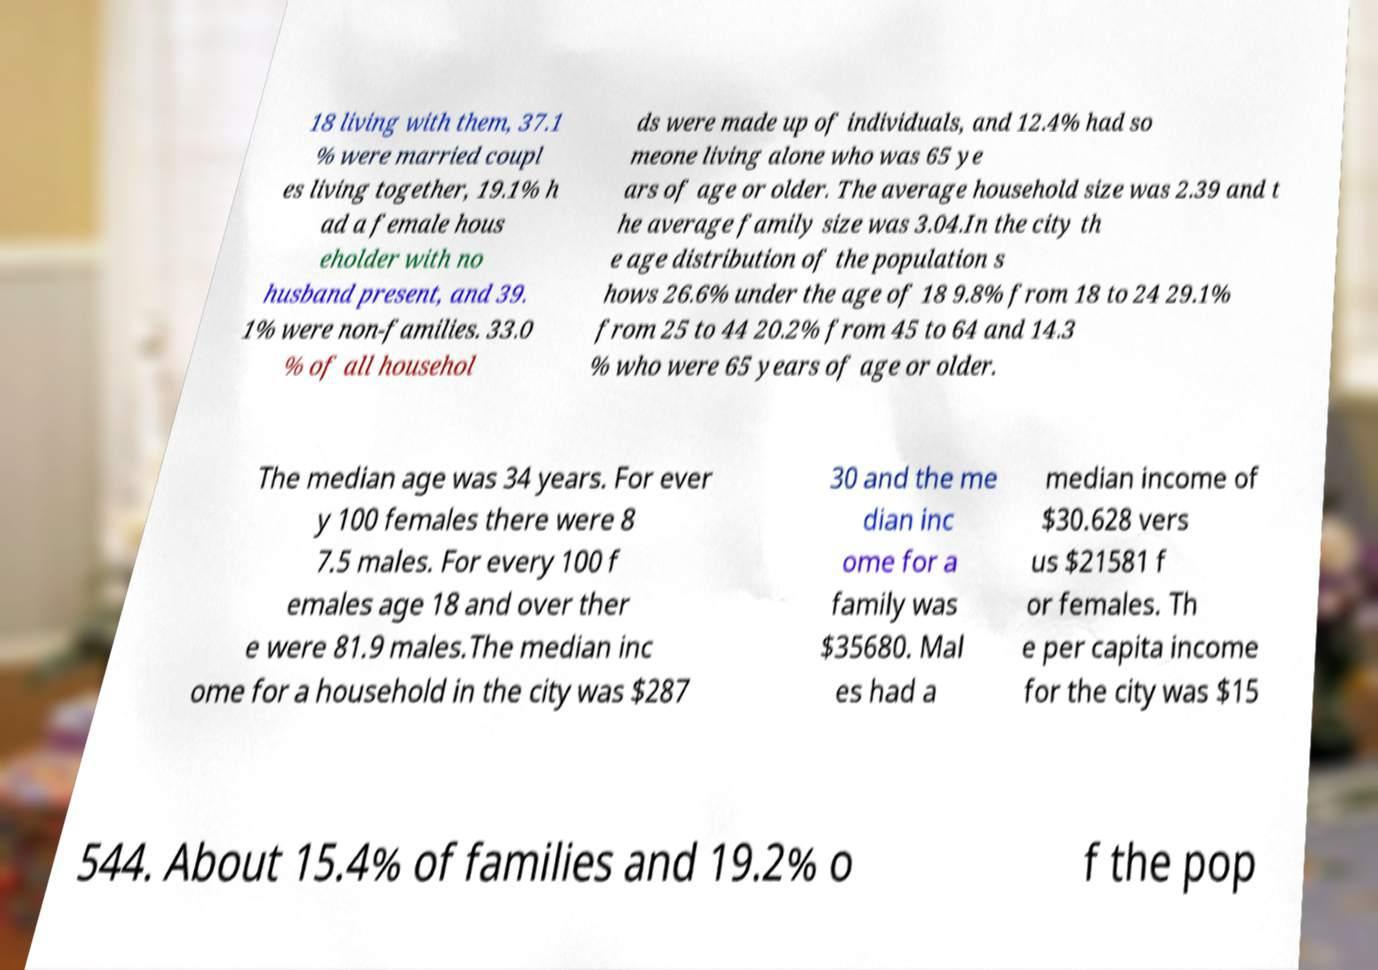Could you assist in decoding the text presented in this image and type it out clearly? 18 living with them, 37.1 % were married coupl es living together, 19.1% h ad a female hous eholder with no husband present, and 39. 1% were non-families. 33.0 % of all househol ds were made up of individuals, and 12.4% had so meone living alone who was 65 ye ars of age or older. The average household size was 2.39 and t he average family size was 3.04.In the city th e age distribution of the population s hows 26.6% under the age of 18 9.8% from 18 to 24 29.1% from 25 to 44 20.2% from 45 to 64 and 14.3 % who were 65 years of age or older. The median age was 34 years. For ever y 100 females there were 8 7.5 males. For every 100 f emales age 18 and over ther e were 81.9 males.The median inc ome for a household in the city was $287 30 and the me dian inc ome for a family was $35680. Mal es had a median income of $30.628 vers us $21581 f or females. Th e per capita income for the city was $15 544. About 15.4% of families and 19.2% o f the pop 